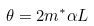<formula> <loc_0><loc_0><loc_500><loc_500>\theta = 2 m ^ { * } \alpha L</formula> 